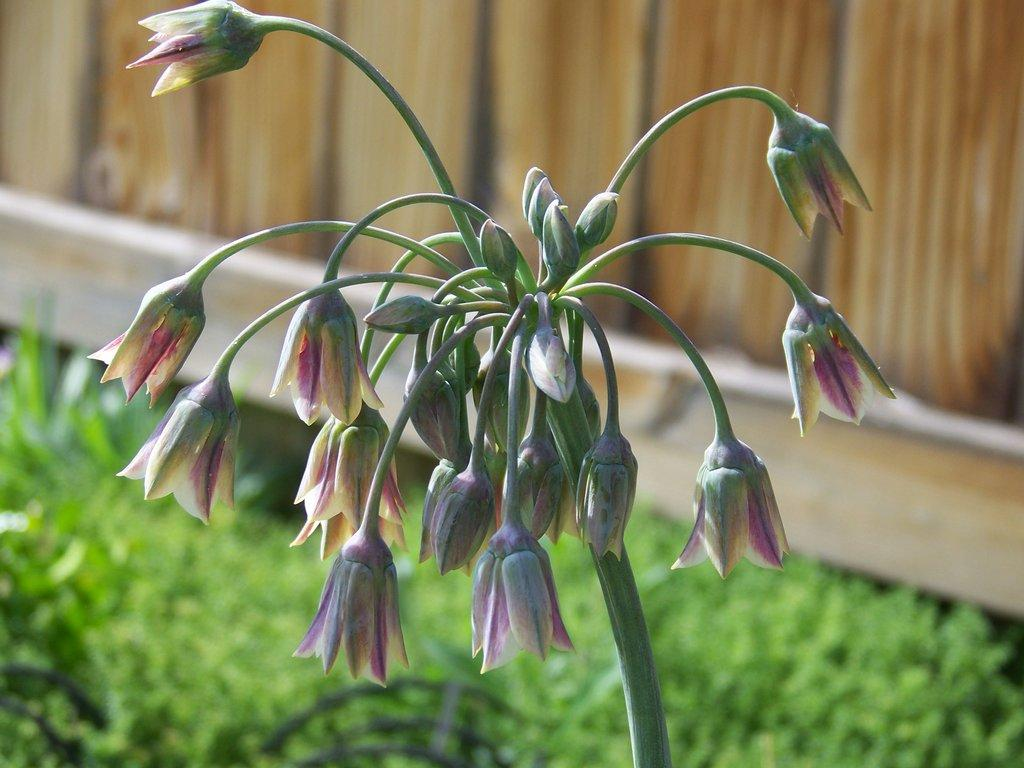What type of vegetation is present in the image? There is a plant, flowers, buds, and grass in the image. What can be seen in the background of the image? There is a wooden wall in the background of the image. What type of shoes can be seen on the plant in the image? There are no shoes present in the image, as it features a plant with flowers, buds, and grass in front of a wooden wall. 